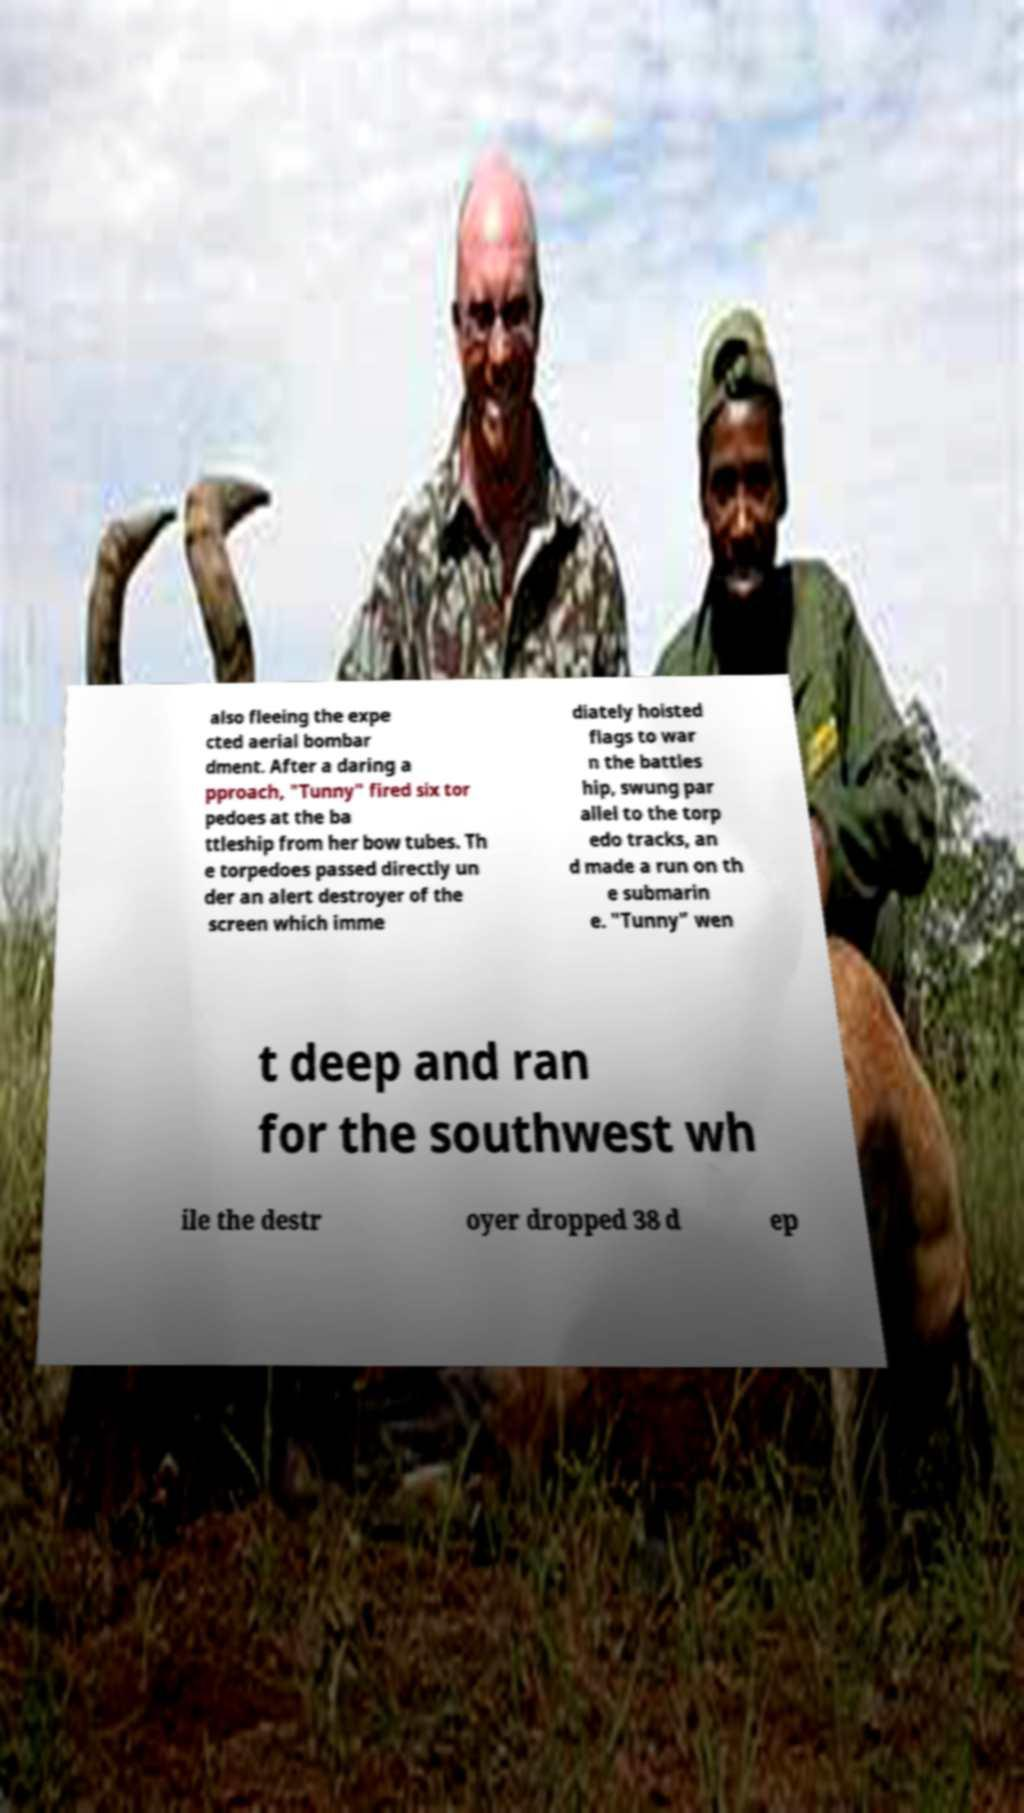Please read and relay the text visible in this image. What does it say? also fleeing the expe cted aerial bombar dment. After a daring a pproach, "Tunny" fired six tor pedoes at the ba ttleship from her bow tubes. Th e torpedoes passed directly un der an alert destroyer of the screen which imme diately hoisted flags to war n the battles hip, swung par allel to the torp edo tracks, an d made a run on th e submarin e. "Tunny" wen t deep and ran for the southwest wh ile the destr oyer dropped 38 d ep 